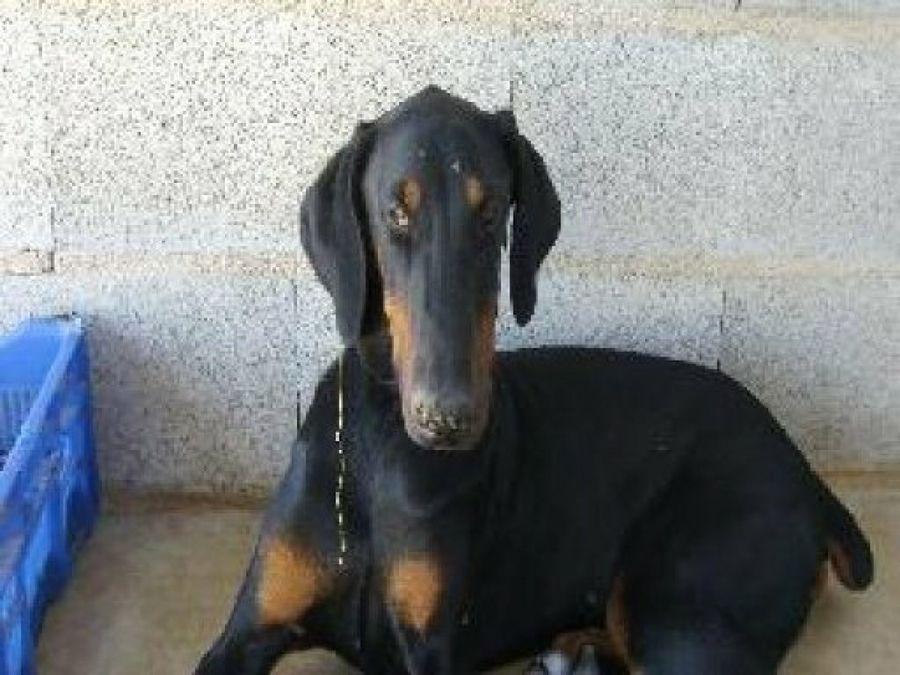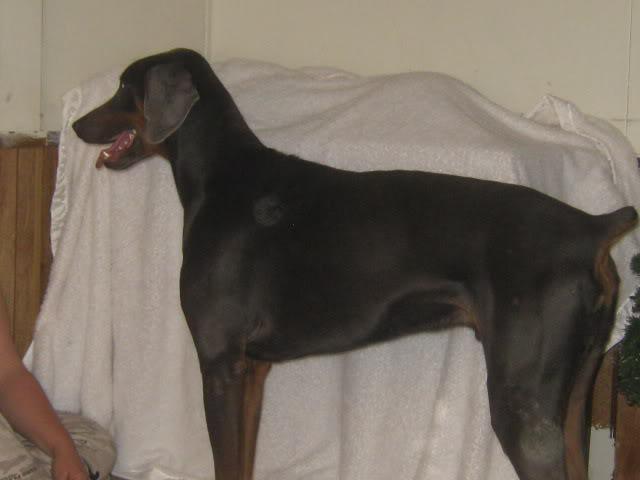The first image is the image on the left, the second image is the image on the right. Analyze the images presented: Is the assertion "A dog's full face is visible." valid? Answer yes or no. Yes. The first image is the image on the left, the second image is the image on the right. Considering the images on both sides, is "Each image shows a dog standing in profile, and the dogs in the left and right images have their bodies turned toward each other." valid? Answer yes or no. No. 